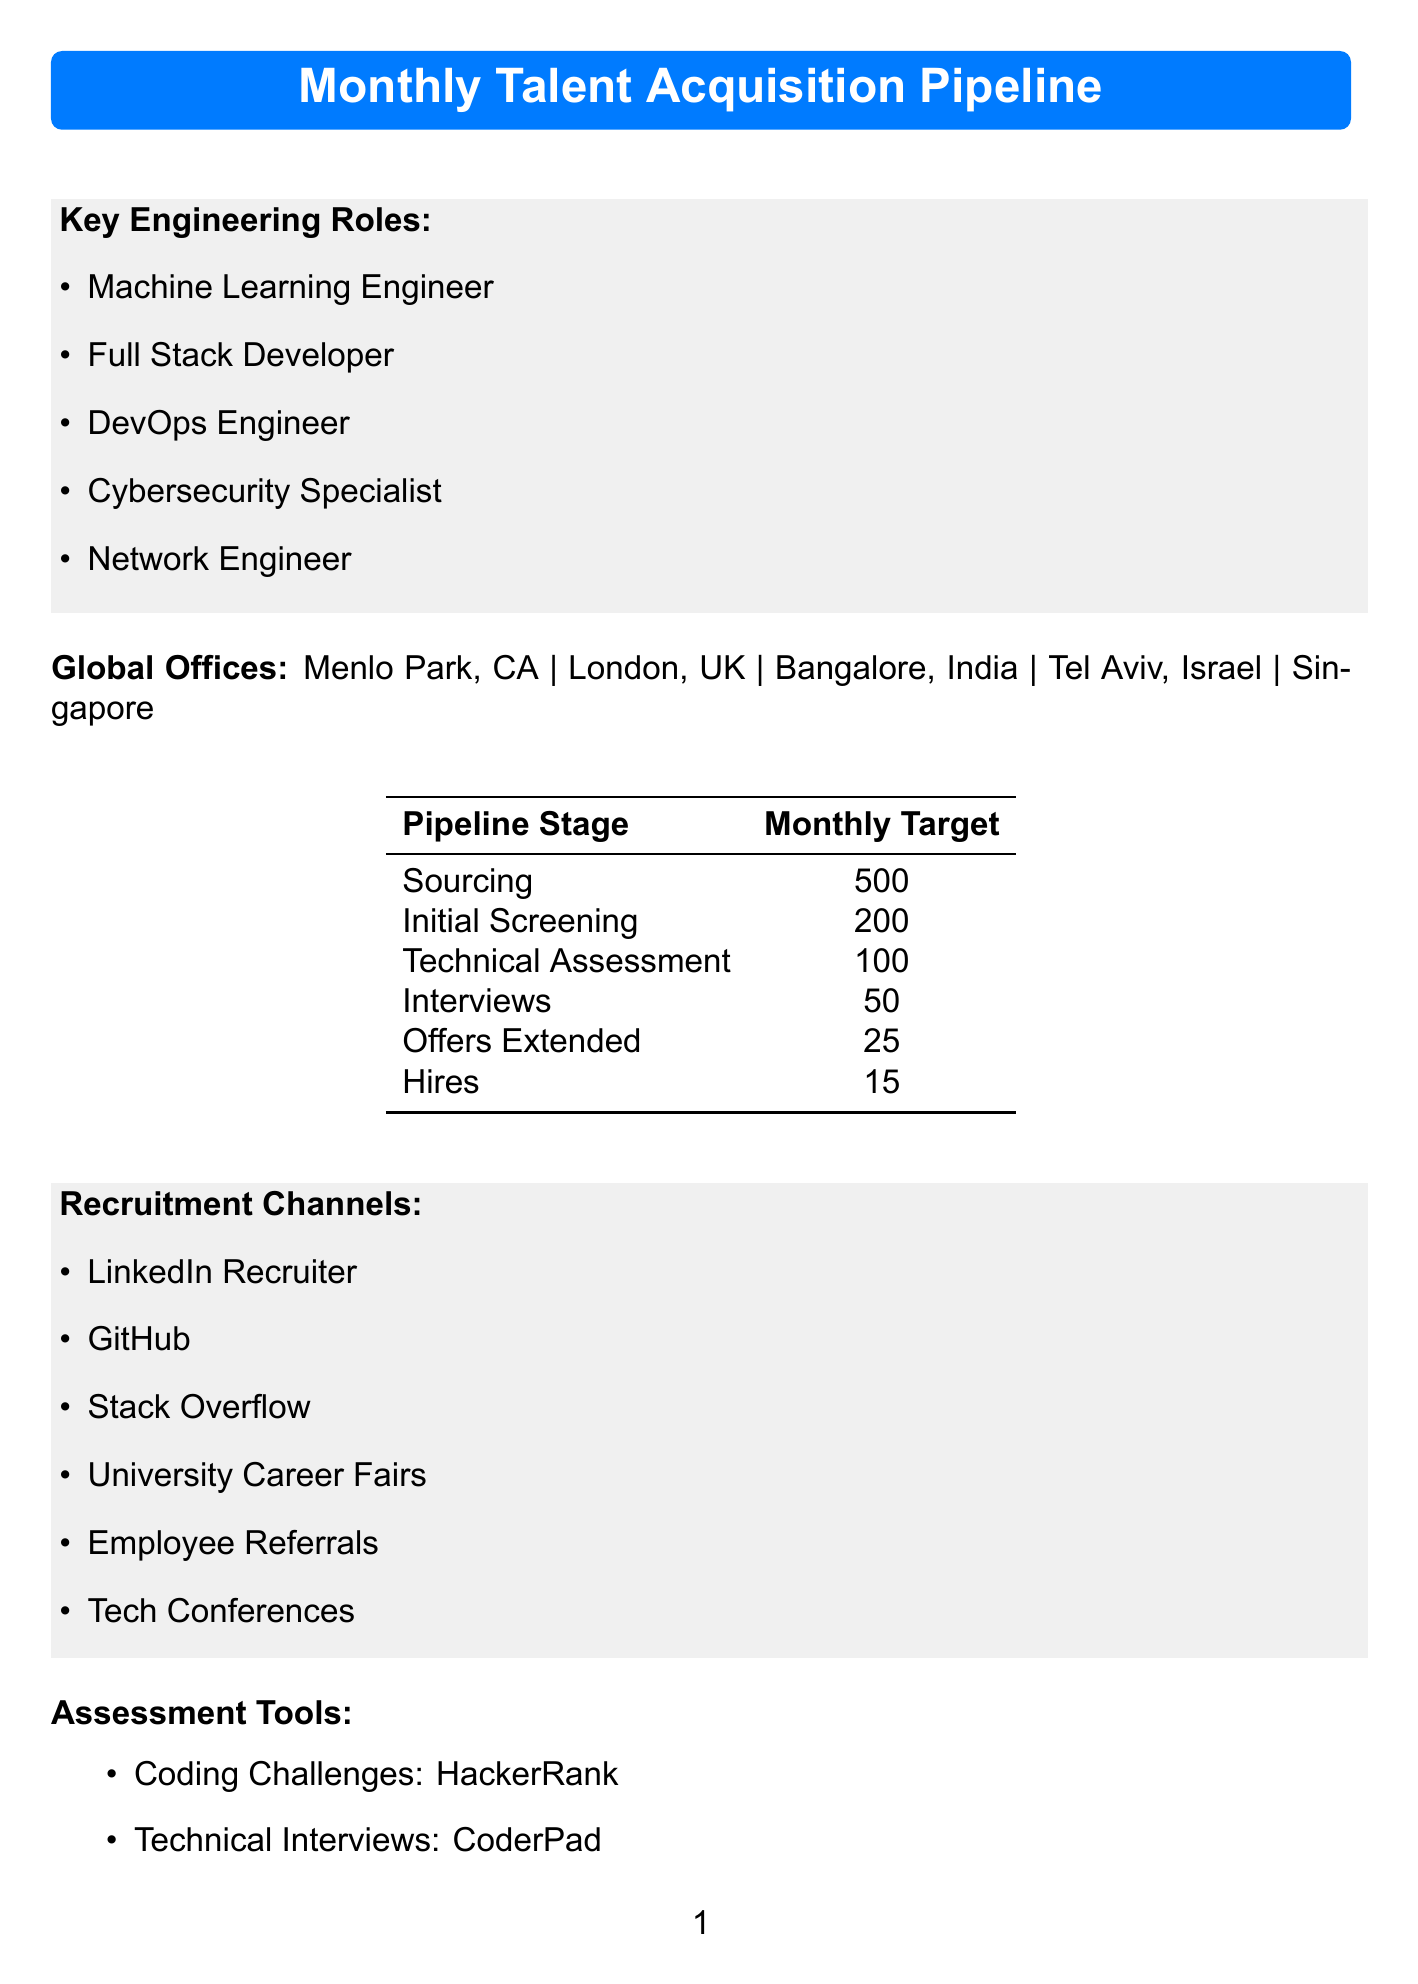What are the key engineering roles? The key engineering roles are listed under "Key Engineering Roles" in the document.
Answer: Machine Learning Engineer, Full Stack Developer, DevOps Engineer, Cybersecurity Specialist, Network Engineer How many hires are targeted monthly? The monthly target for hires is specified in the "Monthly Target" table of the document.
Answer: 15 Who is the global head of talent acquisition? The global head is mentioned in the "Talent Acquisition Team" section of the document.
Answer: Sarah Chen What are the recruitment channels listed? The recruitment channels are outlined in the document under "Recruitment Channels."
Answer: LinkedIn Recruiter, GitHub, Stack Overflow, University Career Fairs, Employee Referrals, Tech Conferences Which diversity initiative focuses on veterans? The diversity initiatives are listed, and the one for veterans can be found there.
Answer: Veteran Hiring Initiative What is the monthly sourcing target? The monthly targeting for sourcing is found in the "Monthly Target" table of the document.
Answer: 500 Who is the regional lead for Europe? The name of the regional lead for Europe is provided in the "Talent Acquisition Team" section.
Answer: Emma Thompson What assessment tool is used for coding challenges? The specific assessment tool for coding challenges is mentioned in the "Assessment Tools" section.
Answer: HackerRank What is the relocation bonus amount? The relocation bonus is specified in the "Relocation Support" section of the document.
Answer: $10,000 